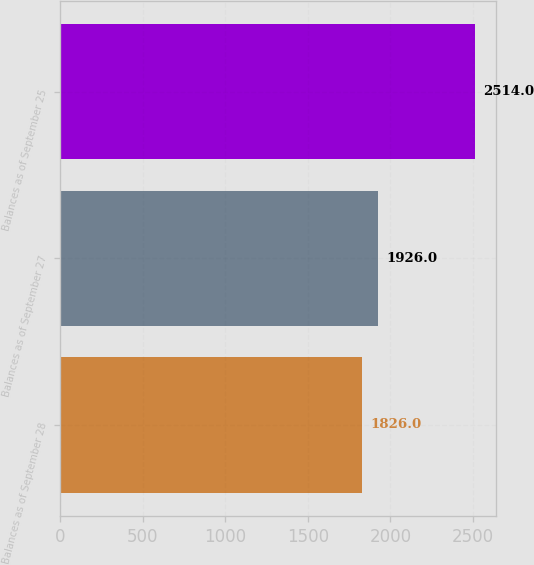<chart> <loc_0><loc_0><loc_500><loc_500><bar_chart><fcel>Balances as of September 28<fcel>Balances as of September 27<fcel>Balances as of September 25<nl><fcel>1826<fcel>1926<fcel>2514<nl></chart> 